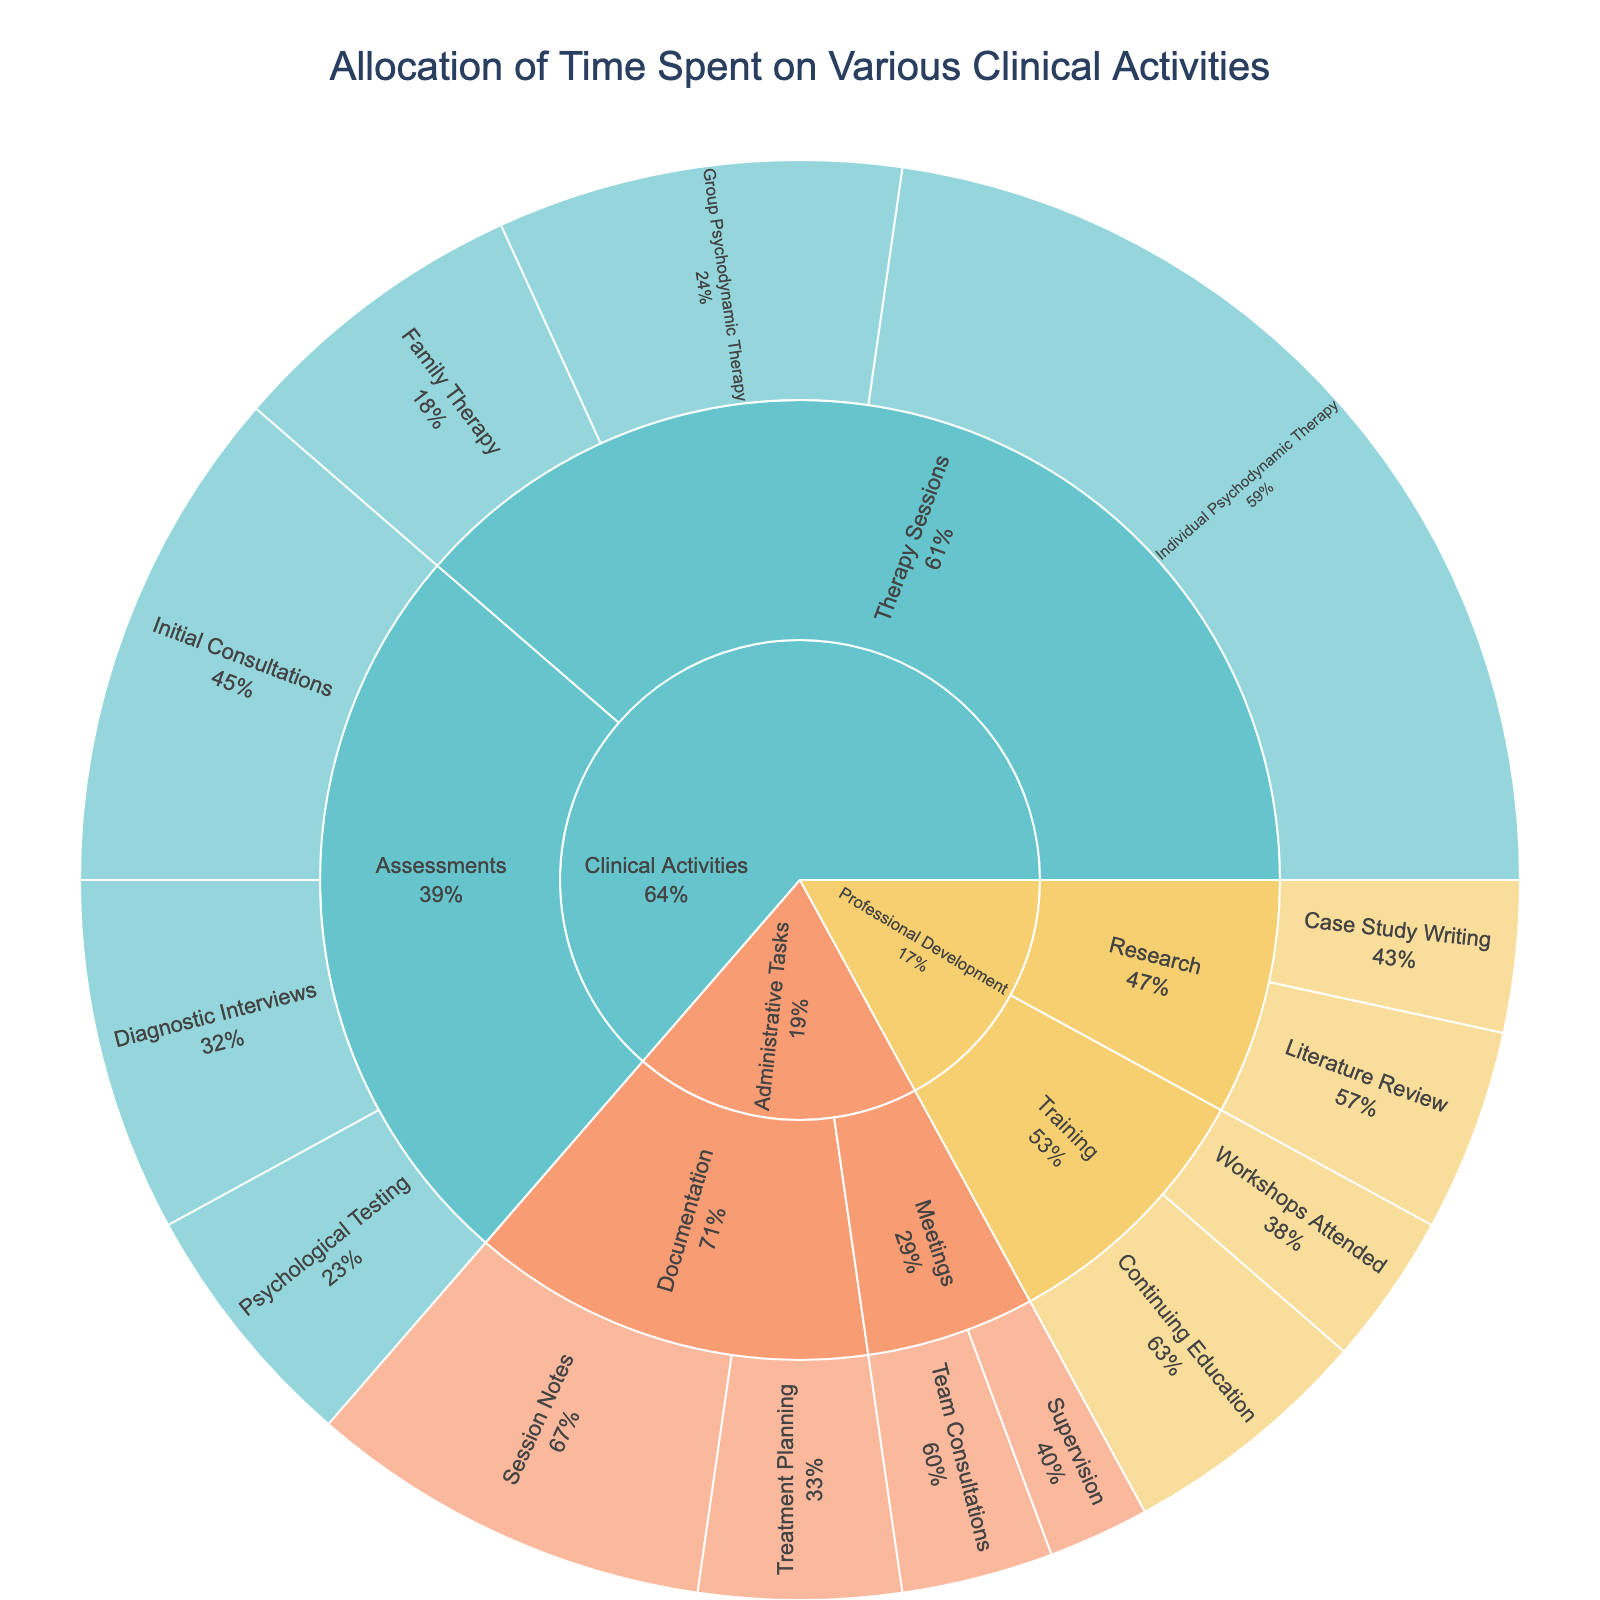What's the title of the figure? The title of the figure is displayed at the top of the plot. By reading it, we see it says "Allocation of Time Spent on Various Clinical Activities."
Answer: Allocation of Time Spent on Various Clinical Activities What percentage of time spent on Therapy Sessions is devoted to Individual Psychodynamic Therapy? Within the Therapy Sessions part of the sunburst, Individual Psychodynamic Therapy is labeled with its percentage of the parent section. By looking at the figure, the percentage is visible.
Answer: 55.6% How many total hours are dedicated to Administrative Tasks? To find the total hours, locate all subcategories under Administrative Tasks and sum their hours: Session Notes (8), Treatment Planning (4), Team Consultations (3), Supervision (2). Add them up: 8 + 4 + 3 + 2 = 17.
Answer: 17 Which subcategory under Professional Development receives the most time? Look under the Professional Development category and compare the size of the arcs representing Research and Training. The figure shows Research (7 hours) and Training (8 hours). The larger arc corresponds to Training.
Answer: Training How much more time is spent on continuing education compared to workshops attended in Professional Development? Locate Continuing Education and Workshops Attended within Training in the Professional Development category. Continuing Education has 5 hours and Workshops Attended has 3 hours. Calculate the difference: 5 - 3 = 2.
Answer: 2 What is the label for the category with the color representing the highest percentage allocation? By observing the figure's color distribution and size of the segments, Therapy Sessions occupy the largest portion of Clinical Activities, denoted with the highest percentage.
Answer: Therapy Sessions Which specific activity within Assessments is allocated the most time? Within the Assessments subcategory, compare Initial Consultations, Psychological Testing, and Diagnostic Interviews. Initial Consultations has the largest arc and hours (10).
Answer: Initial Consultations How does the time spent on Family Therapy compare with time spent on Initial Consultations? Look at the hours dedicated to Family Therapy (6) and Initial Consultations (10) in their respective segments. Initial Consultations has more hours.
Answer: Initial Consultations has 4 more hours than Family Therapy Which activity within Administrative Tasks takes the least amount of time? Navigate through the Administrative Tasks category to find the smallest arc. Supervision has the smallest arc, representing 2 hours.
Answer: Supervision What is the collective percentage of time spent on training-related activities in Professional Development? Combine the percentages within the Training category (Continuing Education and Workshops Attended). Continuing Education has 62.5% of Training, and Workshops Attended has 37.5% of Training.
Answer: 100% of Training 